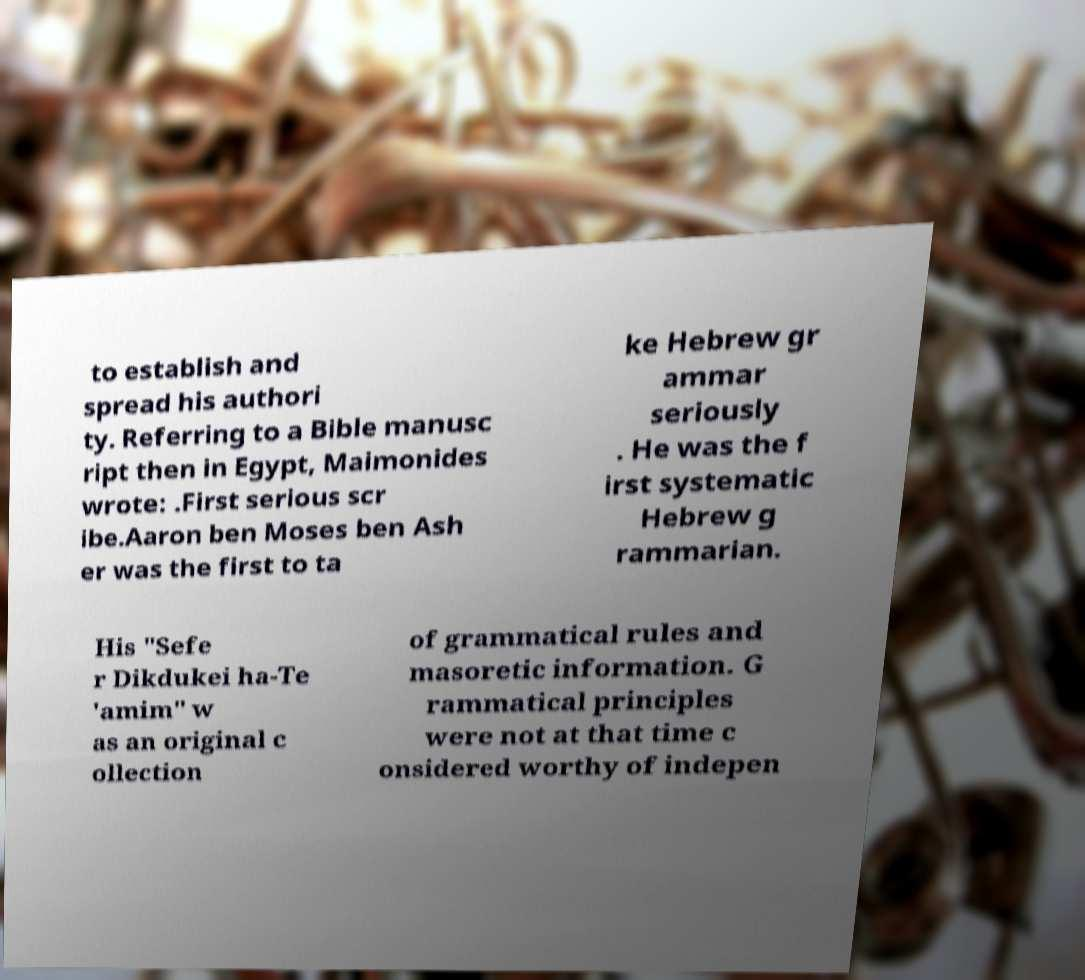There's text embedded in this image that I need extracted. Can you transcribe it verbatim? to establish and spread his authori ty. Referring to a Bible manusc ript then in Egypt, Maimonides wrote: .First serious scr ibe.Aaron ben Moses ben Ash er was the first to ta ke Hebrew gr ammar seriously . He was the f irst systematic Hebrew g rammarian. His "Sefe r Dikdukei ha-Te 'amim" w as an original c ollection of grammatical rules and masoretic information. G rammatical principles were not at that time c onsidered worthy of indepen 